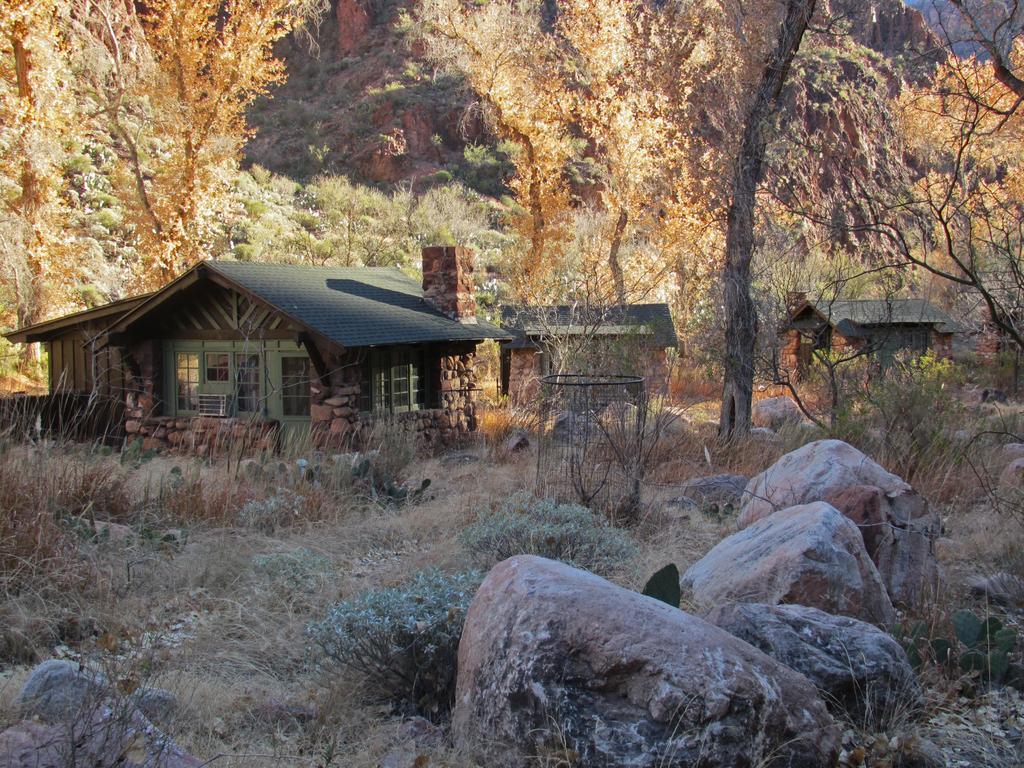Please provide a concise description of this image. In this image, I can see the houses, plants and rocks. In the background, there are trees. 